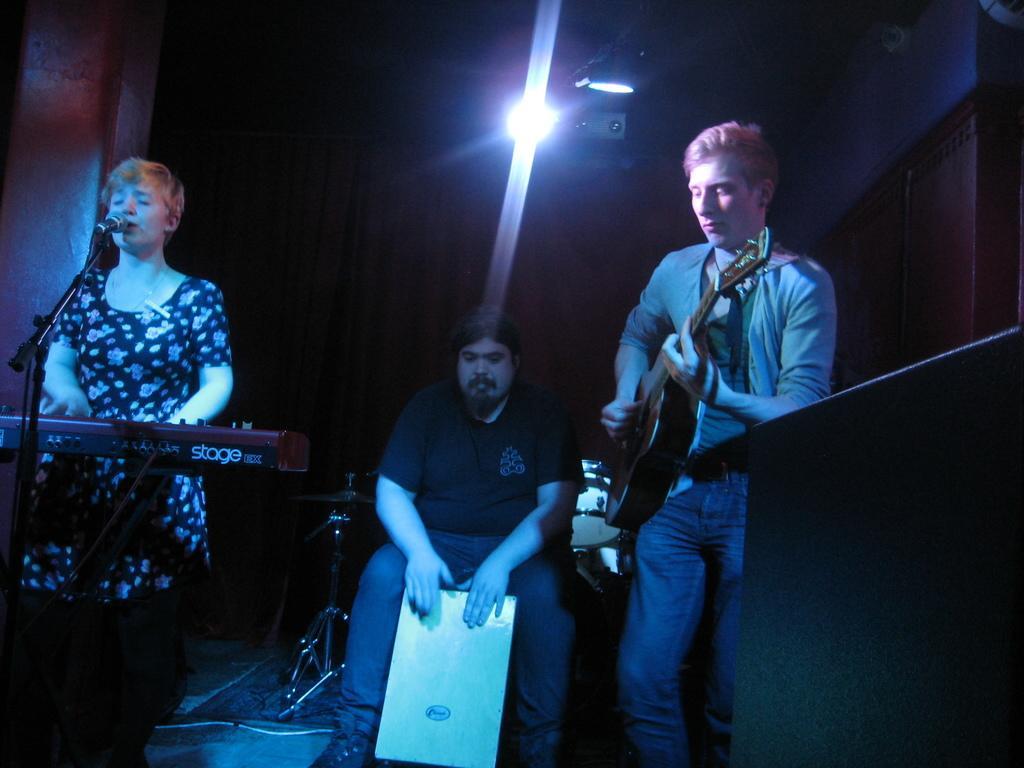Please provide a concise description of this image. In the image we can see there are people who are standing and holding guitar in their hand and another person is playing casio and a person is sitting in between them. 